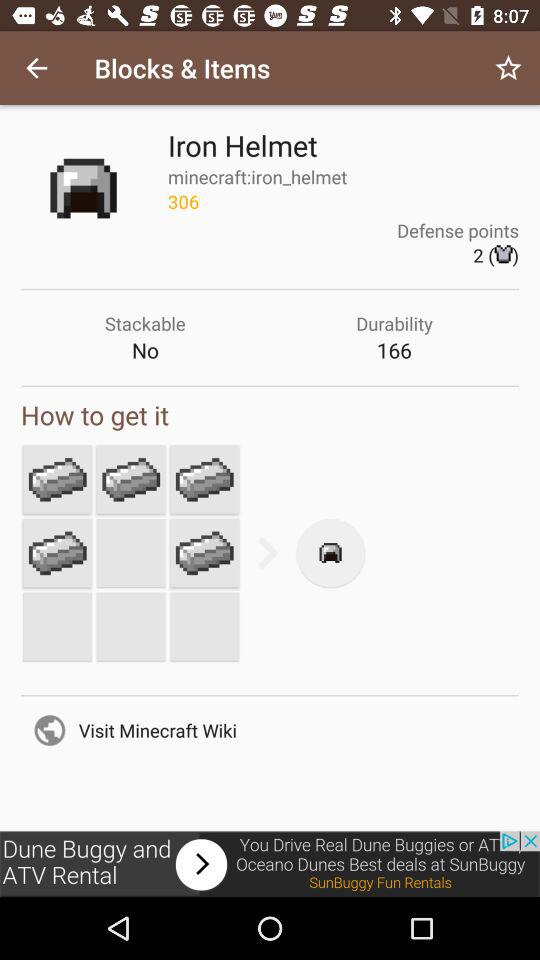What's the number of defense points? The number of defense points is 2. 